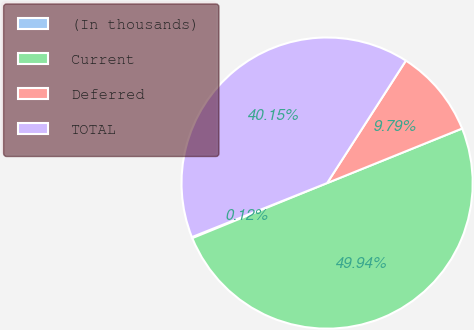Convert chart to OTSL. <chart><loc_0><loc_0><loc_500><loc_500><pie_chart><fcel>(In thousands)<fcel>Current<fcel>Deferred<fcel>TOTAL<nl><fcel>0.12%<fcel>49.94%<fcel>9.79%<fcel>40.15%<nl></chart> 